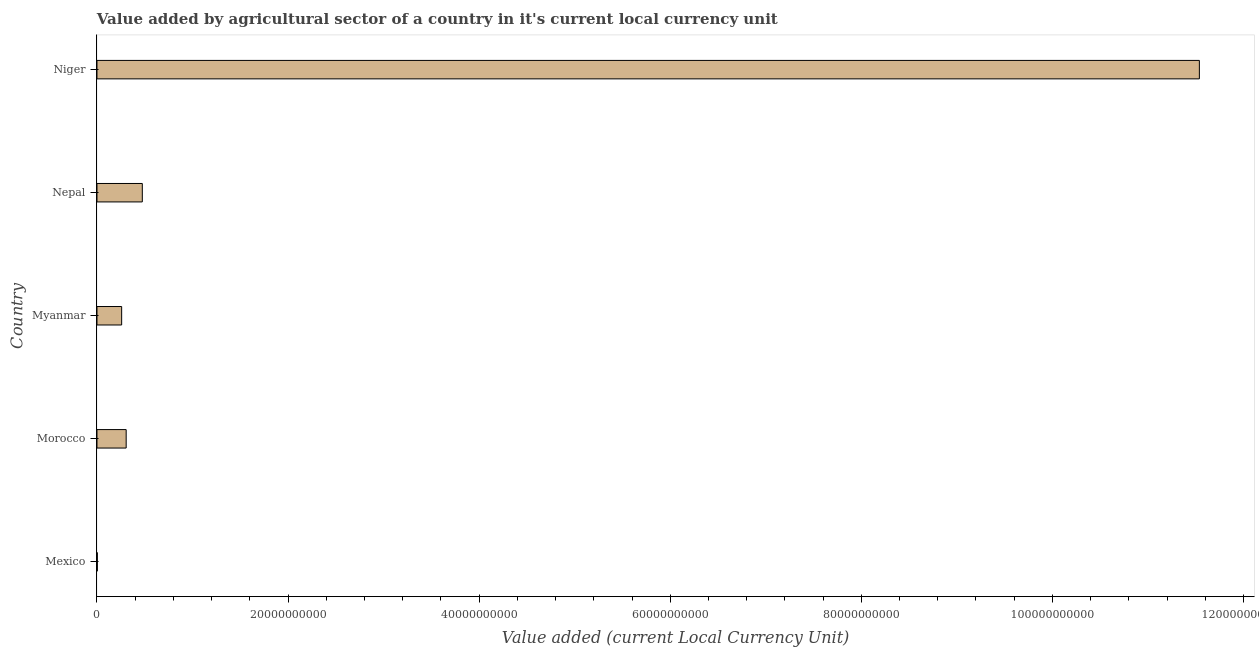Does the graph contain grids?
Provide a succinct answer. No. What is the title of the graph?
Offer a terse response. Value added by agricultural sector of a country in it's current local currency unit. What is the label or title of the X-axis?
Your answer should be very brief. Value added (current Local Currency Unit). What is the label or title of the Y-axis?
Offer a terse response. Country. What is the value added by agriculture sector in Nepal?
Make the answer very short. 4.75e+09. Across all countries, what is the maximum value added by agriculture sector?
Provide a succinct answer. 1.15e+11. Across all countries, what is the minimum value added by agriculture sector?
Offer a very short reply. 3.68e+07. In which country was the value added by agriculture sector maximum?
Your answer should be very brief. Niger. In which country was the value added by agriculture sector minimum?
Your answer should be very brief. Mexico. What is the sum of the value added by agriculture sector?
Make the answer very short. 1.26e+11. What is the difference between the value added by agriculture sector in Morocco and Niger?
Your answer should be compact. -1.12e+11. What is the average value added by agriculture sector per country?
Your answer should be very brief. 2.52e+1. What is the median value added by agriculture sector?
Ensure brevity in your answer.  3.06e+09. In how many countries, is the value added by agriculture sector greater than 24000000000 LCU?
Make the answer very short. 1. What is the ratio of the value added by agriculture sector in Nepal to that in Niger?
Offer a very short reply. 0.04. Is the difference between the value added by agriculture sector in Mexico and Myanmar greater than the difference between any two countries?
Provide a short and direct response. No. What is the difference between the highest and the second highest value added by agriculture sector?
Make the answer very short. 1.11e+11. Is the sum of the value added by agriculture sector in Myanmar and Niger greater than the maximum value added by agriculture sector across all countries?
Give a very brief answer. Yes. What is the difference between the highest and the lowest value added by agriculture sector?
Provide a short and direct response. 1.15e+11. What is the Value added (current Local Currency Unit) in Mexico?
Ensure brevity in your answer.  3.68e+07. What is the Value added (current Local Currency Unit) in Morocco?
Offer a terse response. 3.06e+09. What is the Value added (current Local Currency Unit) in Myanmar?
Ensure brevity in your answer.  2.58e+09. What is the Value added (current Local Currency Unit) in Nepal?
Your response must be concise. 4.75e+09. What is the Value added (current Local Currency Unit) of Niger?
Offer a terse response. 1.15e+11. What is the difference between the Value added (current Local Currency Unit) in Mexico and Morocco?
Offer a terse response. -3.02e+09. What is the difference between the Value added (current Local Currency Unit) in Mexico and Myanmar?
Your answer should be very brief. -2.55e+09. What is the difference between the Value added (current Local Currency Unit) in Mexico and Nepal?
Provide a short and direct response. -4.71e+09. What is the difference between the Value added (current Local Currency Unit) in Mexico and Niger?
Keep it short and to the point. -1.15e+11. What is the difference between the Value added (current Local Currency Unit) in Morocco and Myanmar?
Your answer should be very brief. 4.73e+08. What is the difference between the Value added (current Local Currency Unit) in Morocco and Nepal?
Offer a very short reply. -1.69e+09. What is the difference between the Value added (current Local Currency Unit) in Morocco and Niger?
Keep it short and to the point. -1.12e+11. What is the difference between the Value added (current Local Currency Unit) in Myanmar and Nepal?
Offer a very short reply. -2.16e+09. What is the difference between the Value added (current Local Currency Unit) in Myanmar and Niger?
Offer a very short reply. -1.13e+11. What is the difference between the Value added (current Local Currency Unit) in Nepal and Niger?
Provide a short and direct response. -1.11e+11. What is the ratio of the Value added (current Local Currency Unit) in Mexico to that in Morocco?
Provide a succinct answer. 0.01. What is the ratio of the Value added (current Local Currency Unit) in Mexico to that in Myanmar?
Offer a terse response. 0.01. What is the ratio of the Value added (current Local Currency Unit) in Mexico to that in Nepal?
Provide a short and direct response. 0.01. What is the ratio of the Value added (current Local Currency Unit) in Mexico to that in Niger?
Offer a very short reply. 0. What is the ratio of the Value added (current Local Currency Unit) in Morocco to that in Myanmar?
Offer a very short reply. 1.18. What is the ratio of the Value added (current Local Currency Unit) in Morocco to that in Nepal?
Offer a very short reply. 0.64. What is the ratio of the Value added (current Local Currency Unit) in Morocco to that in Niger?
Offer a terse response. 0.03. What is the ratio of the Value added (current Local Currency Unit) in Myanmar to that in Nepal?
Provide a short and direct response. 0.54. What is the ratio of the Value added (current Local Currency Unit) in Myanmar to that in Niger?
Ensure brevity in your answer.  0.02. What is the ratio of the Value added (current Local Currency Unit) in Nepal to that in Niger?
Keep it short and to the point. 0.04. 